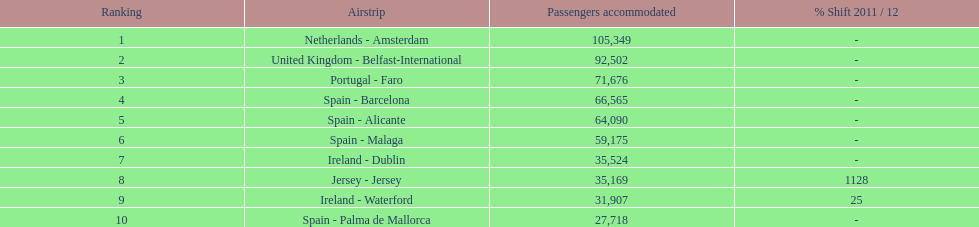Which airport has no more than 30,000 passengers handled among the 10 busiest routes to and from london southend airport in 2012? Spain - Palma de Mallorca. 